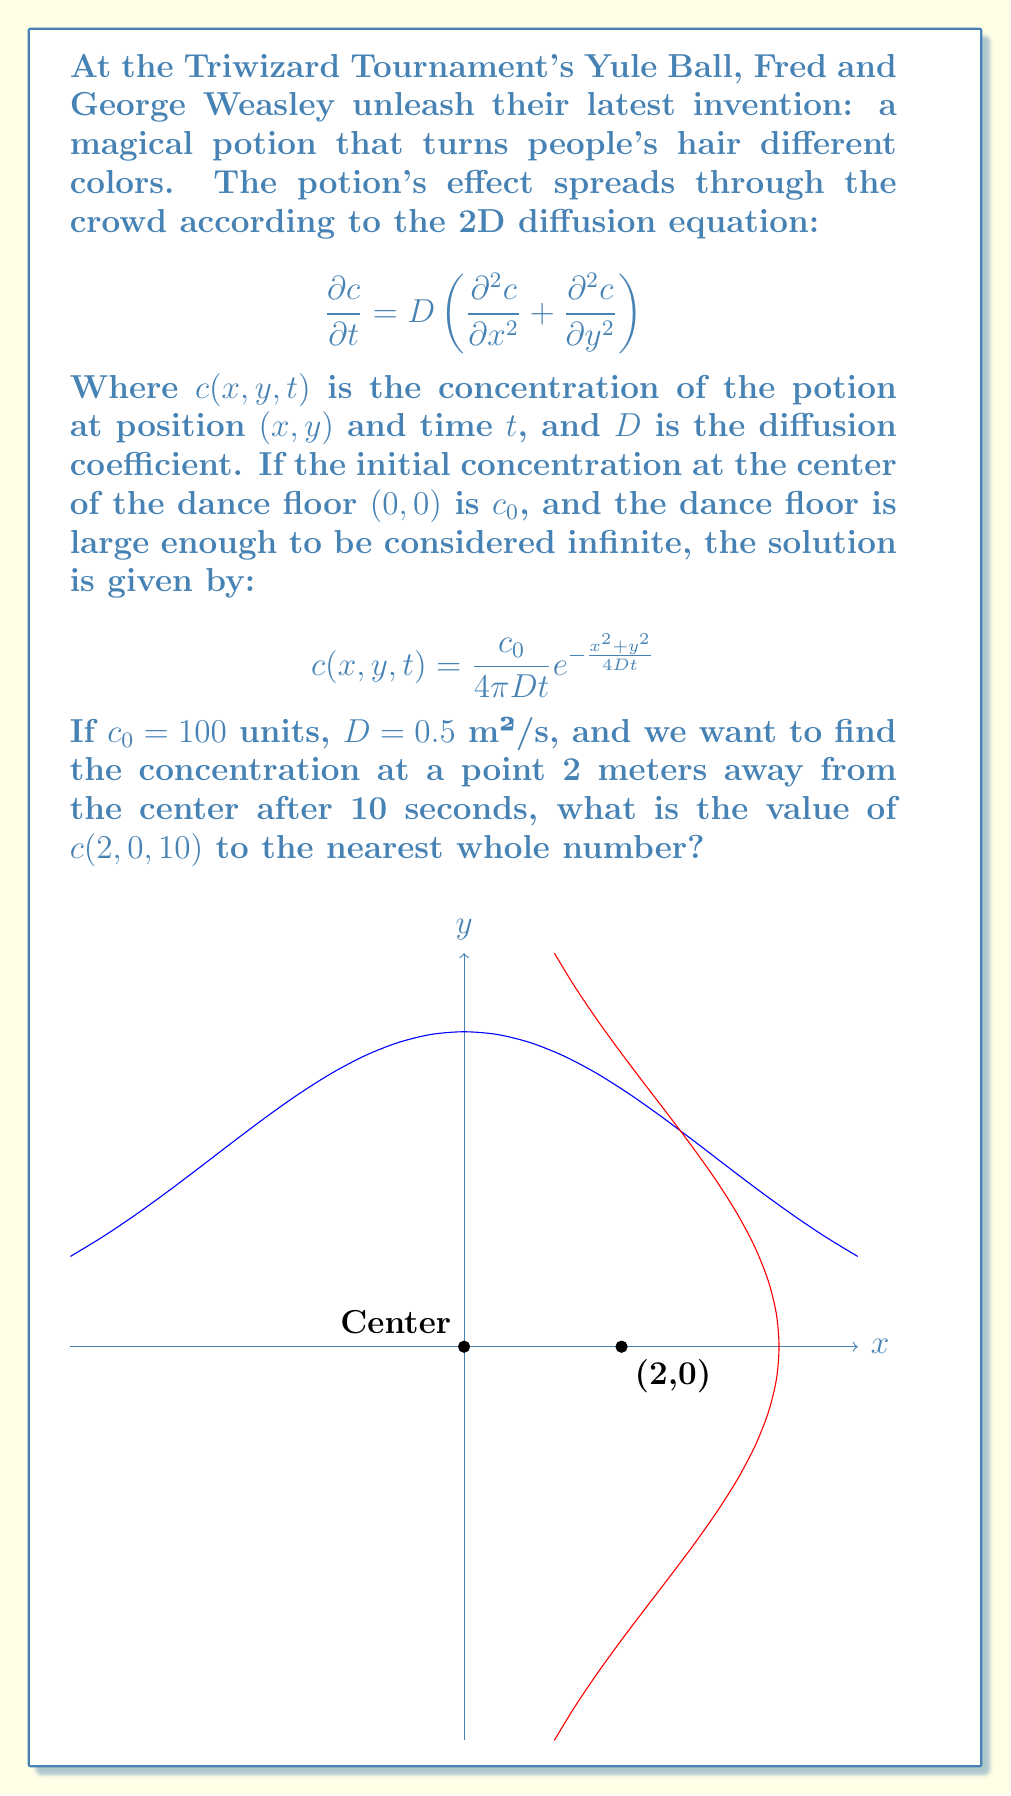Can you answer this question? Let's approach this step-by-step:

1) We are given:
   $c_0 = 100$ units
   $D = 0.5$ m²/s
   $t = 10$ s
   $x = 2$ m, $y = 0$ m

2) We need to use the equation:
   $$c(x,y,t) = \frac{c_0}{4\pi Dt} e^{-\frac{x^2+y^2}{4Dt}}$$

3) Let's substitute the values:
   $$c(2,0,10) = \frac{100}{4\pi(0.5)(10)} e^{-\frac{2^2+0^2}{4(0.5)(10)}}$$

4) Simplify the denominator in the fraction:
   $$c(2,0,10) = \frac{100}{20\pi} e^{-\frac{4}{20}}$$

5) Simplify the exponent:
   $$c(2,0,10) = \frac{100}{20\pi} e^{-0.2}$$

6) Calculate the value of $e^{-0.2}$:
   $$c(2,0,10) = \frac{100}{20\pi} (0.8187)$$

7) Multiply:
   $$c(2,0,10) = \frac{81.87}{20\pi} \approx 1.3013$$

8) Rounding to the nearest whole number:
   $$c(2,0,10) \approx 1$$
Answer: 1 